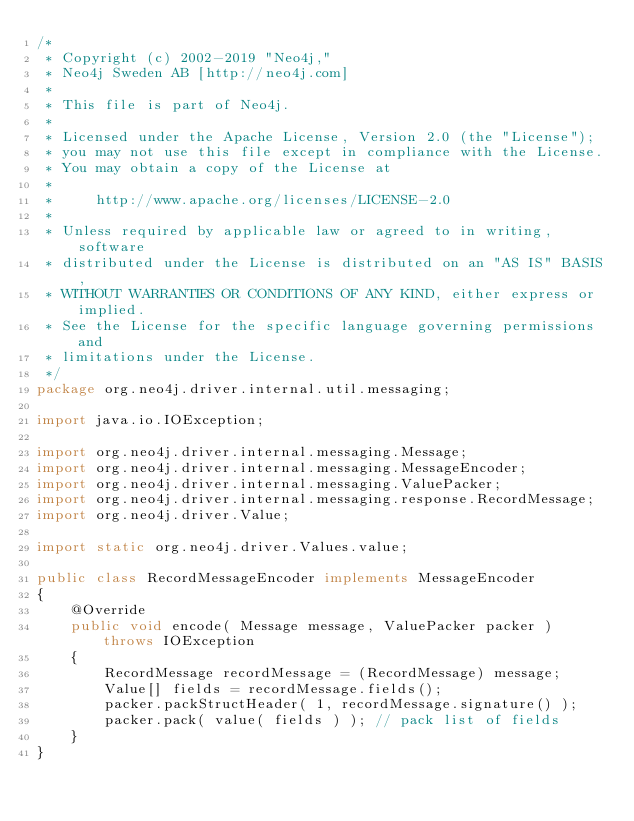<code> <loc_0><loc_0><loc_500><loc_500><_Java_>/*
 * Copyright (c) 2002-2019 "Neo4j,"
 * Neo4j Sweden AB [http://neo4j.com]
 *
 * This file is part of Neo4j.
 *
 * Licensed under the Apache License, Version 2.0 (the "License");
 * you may not use this file except in compliance with the License.
 * You may obtain a copy of the License at
 *
 *     http://www.apache.org/licenses/LICENSE-2.0
 *
 * Unless required by applicable law or agreed to in writing, software
 * distributed under the License is distributed on an "AS IS" BASIS,
 * WITHOUT WARRANTIES OR CONDITIONS OF ANY KIND, either express or implied.
 * See the License for the specific language governing permissions and
 * limitations under the License.
 */
package org.neo4j.driver.internal.util.messaging;

import java.io.IOException;

import org.neo4j.driver.internal.messaging.Message;
import org.neo4j.driver.internal.messaging.MessageEncoder;
import org.neo4j.driver.internal.messaging.ValuePacker;
import org.neo4j.driver.internal.messaging.response.RecordMessage;
import org.neo4j.driver.Value;

import static org.neo4j.driver.Values.value;

public class RecordMessageEncoder implements MessageEncoder
{
    @Override
    public void encode( Message message, ValuePacker packer ) throws IOException
    {
        RecordMessage recordMessage = (RecordMessage) message;
        Value[] fields = recordMessage.fields();
        packer.packStructHeader( 1, recordMessage.signature() );
        packer.pack( value( fields ) ); // pack list of fields
    }
}
</code> 